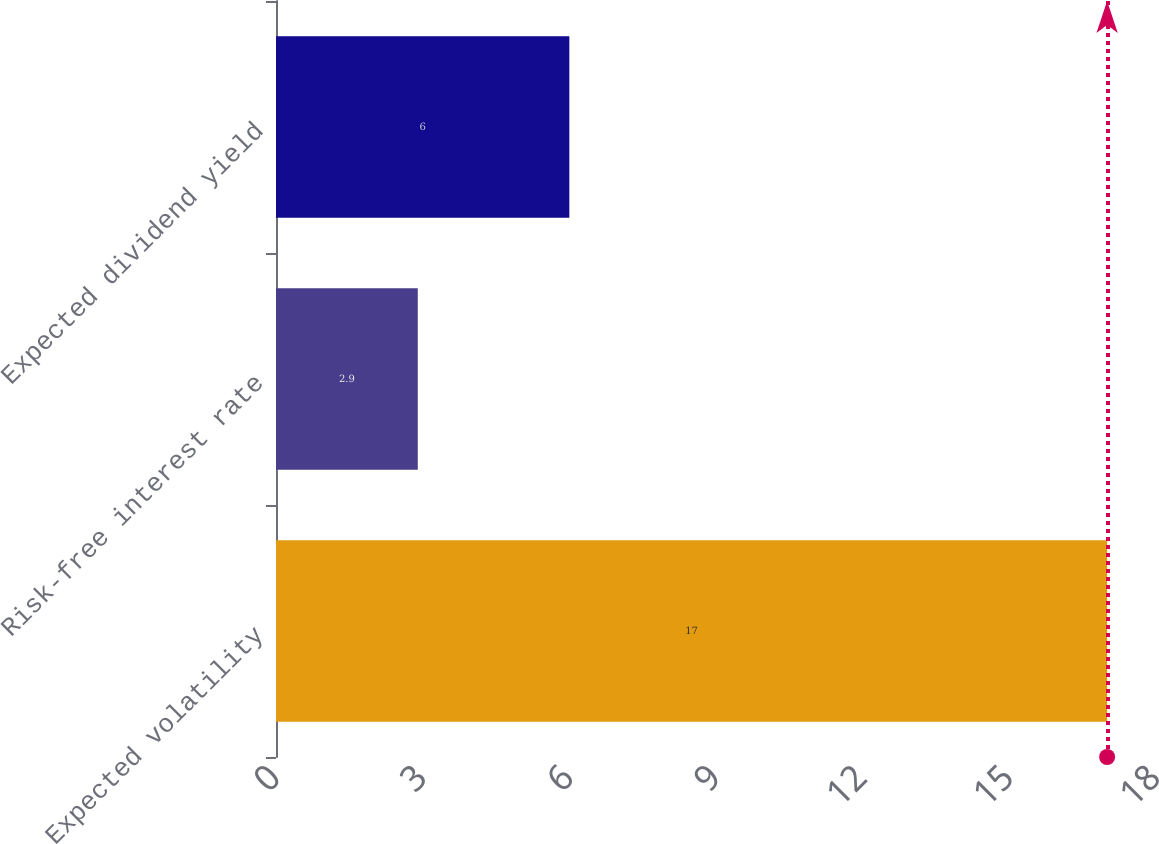Convert chart to OTSL. <chart><loc_0><loc_0><loc_500><loc_500><bar_chart><fcel>Expected volatility<fcel>Risk-free interest rate<fcel>Expected dividend yield<nl><fcel>17<fcel>2.9<fcel>6<nl></chart> 